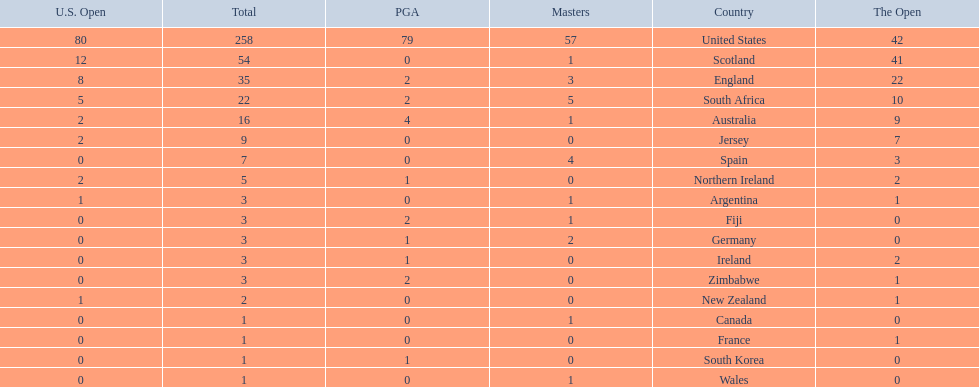What are all the countries? United States, Scotland, England, South Africa, Australia, Jersey, Spain, Northern Ireland, Argentina, Fiji, Germany, Ireland, Zimbabwe, New Zealand, Canada, France, South Korea, Wales. Which ones are located in africa? South Africa, Zimbabwe. Of those, which has the least champion golfers? Zimbabwe. 